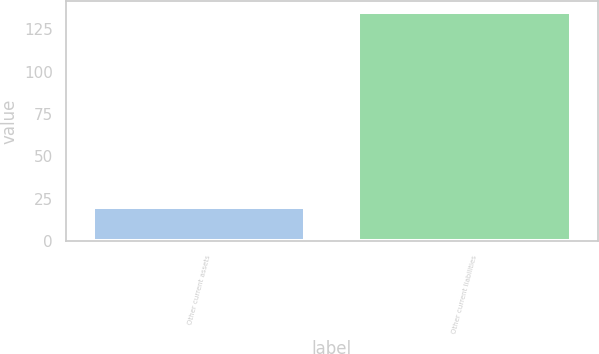Convert chart to OTSL. <chart><loc_0><loc_0><loc_500><loc_500><bar_chart><fcel>Other current assets<fcel>Other current liabilities<nl><fcel>20<fcel>135<nl></chart> 